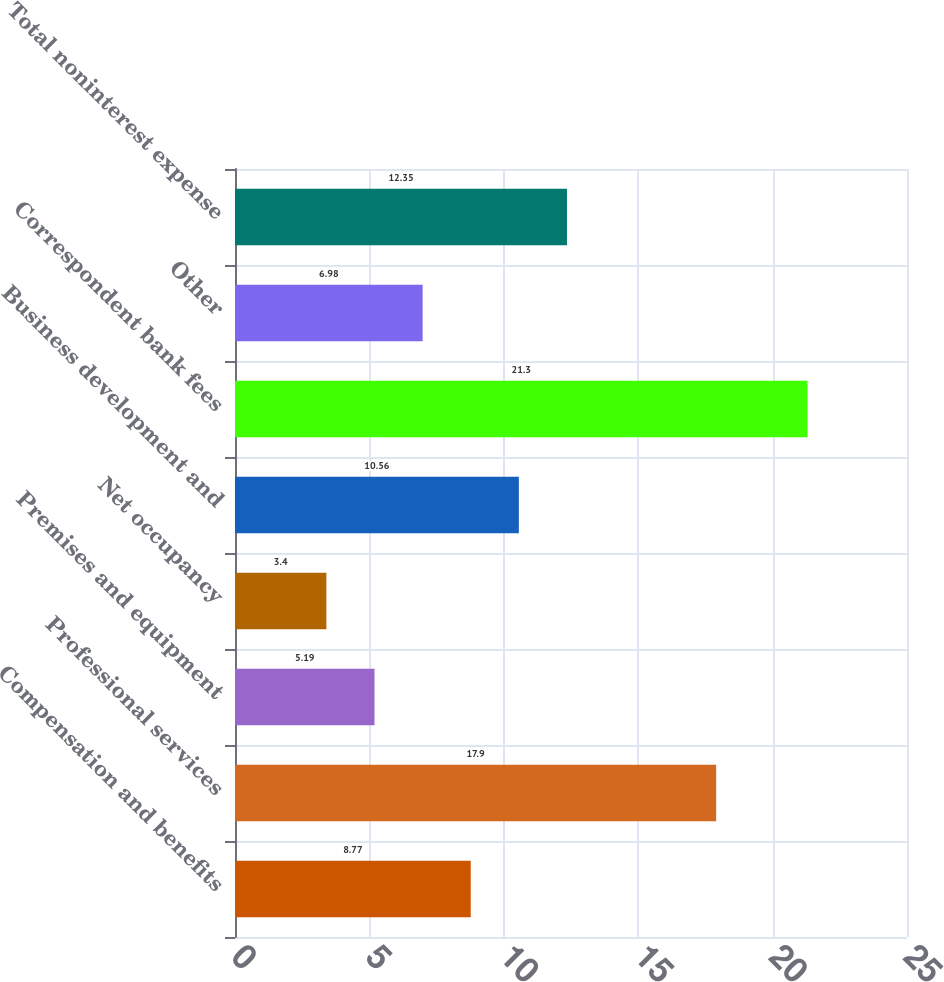<chart> <loc_0><loc_0><loc_500><loc_500><bar_chart><fcel>Compensation and benefits<fcel>Professional services<fcel>Premises and equipment<fcel>Net occupancy<fcel>Business development and<fcel>Correspondent bank fees<fcel>Other<fcel>Total noninterest expense<nl><fcel>8.77<fcel>17.9<fcel>5.19<fcel>3.4<fcel>10.56<fcel>21.3<fcel>6.98<fcel>12.35<nl></chart> 